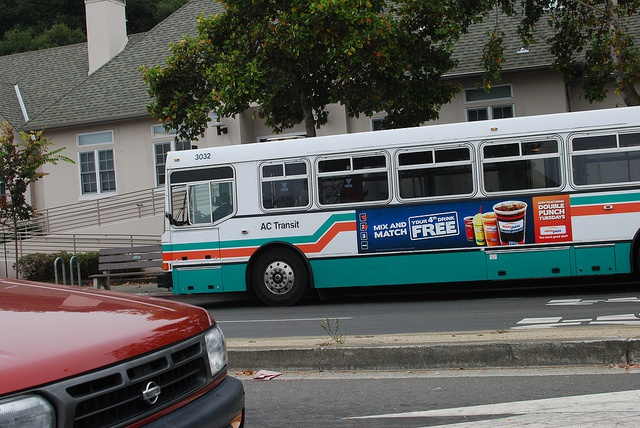Describe the objects in this image and their specific colors. I can see bus in black, lightgray, teal, and darkgray tones, truck in black, darkgray, brown, and gray tones, car in black, darkgray, brown, and maroon tones, and bench in black, gray, and darkgray tones in this image. 